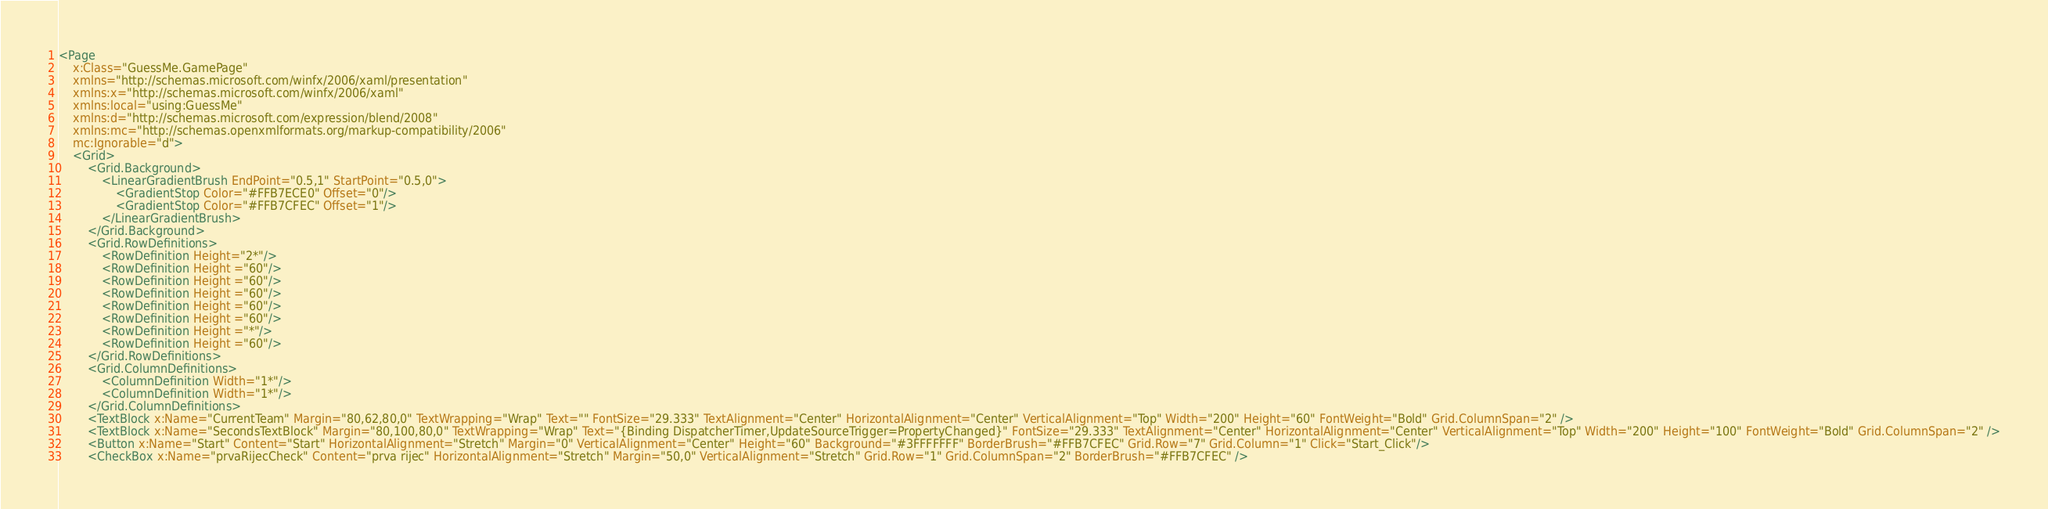Convert code to text. <code><loc_0><loc_0><loc_500><loc_500><_XML_><Page
    x:Class="GuessMe.GamePage"
    xmlns="http://schemas.microsoft.com/winfx/2006/xaml/presentation"
    xmlns:x="http://schemas.microsoft.com/winfx/2006/xaml"
    xmlns:local="using:GuessMe"
    xmlns:d="http://schemas.microsoft.com/expression/blend/2008"
    xmlns:mc="http://schemas.openxmlformats.org/markup-compatibility/2006"
    mc:Ignorable="d">
    <Grid>
        <Grid.Background>
            <LinearGradientBrush EndPoint="0.5,1" StartPoint="0.5,0">
                <GradientStop Color="#FFB7ECE0" Offset="0"/>
                <GradientStop Color="#FFB7CFEC" Offset="1"/>
            </LinearGradientBrush>
        </Grid.Background>
        <Grid.RowDefinitions>
            <RowDefinition Height="2*"/>
            <RowDefinition Height ="60"/>
            <RowDefinition Height ="60"/>
            <RowDefinition Height ="60"/>
            <RowDefinition Height ="60"/>
            <RowDefinition Height ="60"/>
            <RowDefinition Height ="*"/>
            <RowDefinition Height ="60"/>
        </Grid.RowDefinitions>
        <Grid.ColumnDefinitions>
            <ColumnDefinition Width="1*"/>
            <ColumnDefinition Width="1*"/>
        </Grid.ColumnDefinitions>
        <TextBlock x:Name="CurrentTeam" Margin="80,62,80,0" TextWrapping="Wrap" Text="" FontSize="29.333" TextAlignment="Center" HorizontalAlignment="Center" VerticalAlignment="Top" Width="200" Height="60" FontWeight="Bold" Grid.ColumnSpan="2" />
        <TextBlock x:Name="SecondsTextBlock" Margin="80,100,80,0" TextWrapping="Wrap" Text="{Binding DispatcherTimer,UpdateSourceTrigger=PropertyChanged}" FontSize="29.333" TextAlignment="Center" HorizontalAlignment="Center" VerticalAlignment="Top" Width="200" Height="100" FontWeight="Bold" Grid.ColumnSpan="2" />
        <Button x:Name="Start" Content="Start" HorizontalAlignment="Stretch" Margin="0" VerticalAlignment="Center" Height="60" Background="#3FFFFFFF" BorderBrush="#FFB7CFEC" Grid.Row="7" Grid.Column="1" Click="Start_Click"/>
        <CheckBox x:Name="prvaRijecCheck" Content="prva rijec" HorizontalAlignment="Stretch" Margin="50,0" VerticalAlignment="Stretch" Grid.Row="1" Grid.ColumnSpan="2" BorderBrush="#FFB7CFEC" /></code> 